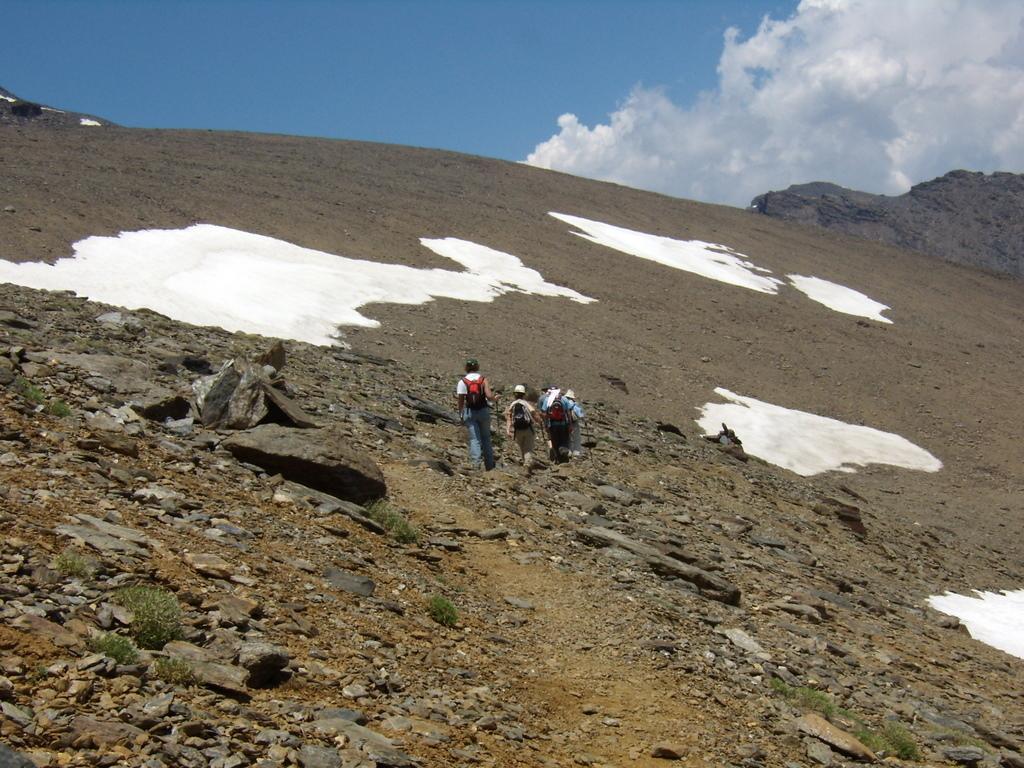How would you summarize this image in a sentence or two? In the image we can see there are people walking, they are wearing clothes, cap and they are carrying a bag on their back. There are the stones, grass, snow and a cloudy sky. 